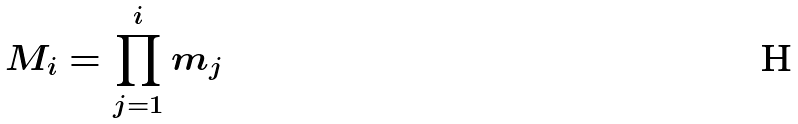<formula> <loc_0><loc_0><loc_500><loc_500>M _ { i } = \prod _ { j = 1 } ^ { i } m _ { j }</formula> 